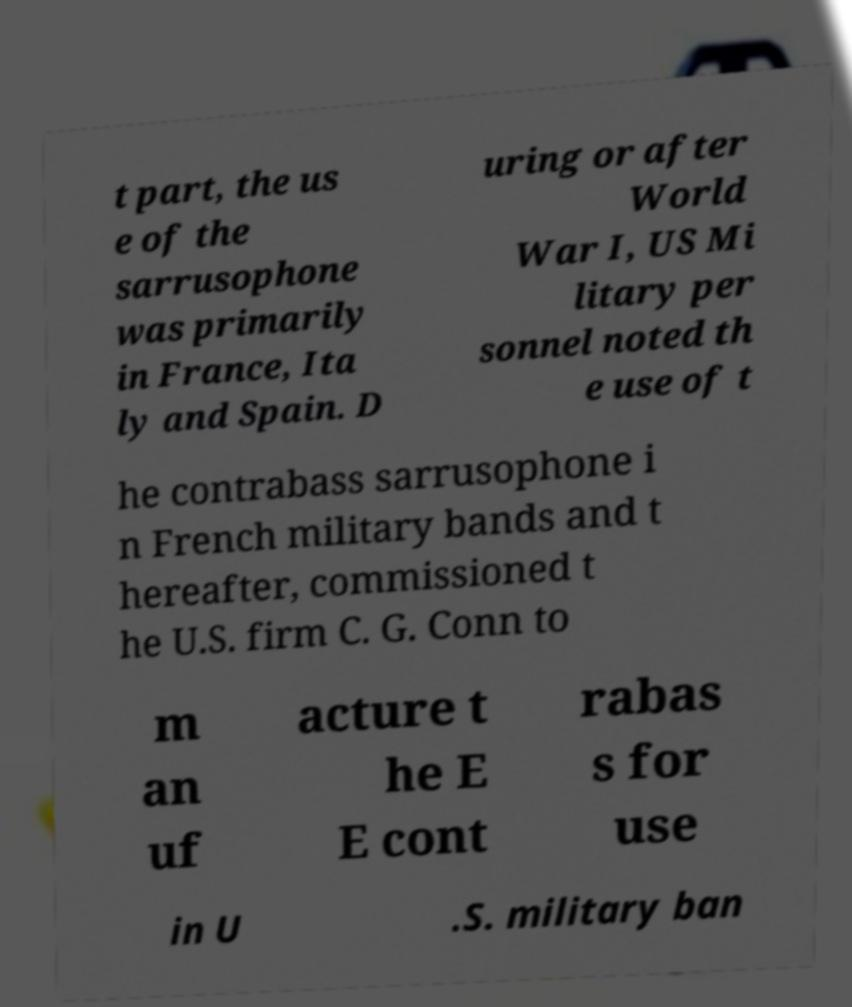I need the written content from this picture converted into text. Can you do that? t part, the us e of the sarrusophone was primarily in France, Ita ly and Spain. D uring or after World War I, US Mi litary per sonnel noted th e use of t he contrabass sarrusophone i n French military bands and t hereafter, commissioned t he U.S. firm C. G. Conn to m an uf acture t he E E cont rabas s for use in U .S. military ban 